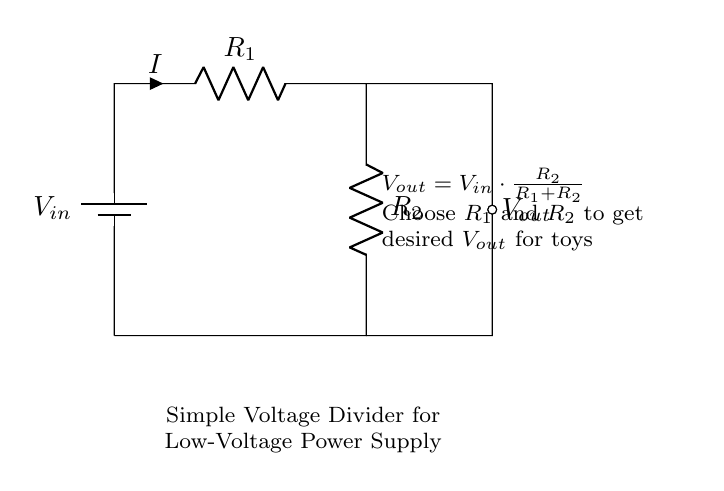What is the type of this circuit? This circuit is a voltage divider, which is specifically designed to produce a low voltage output from a higher voltage supply by using two resistors.
Answer: Voltage divider What are the components in the circuit? The components in this circuit are a battery, two resistors (R1 and R2), and a voltage output point. Each of these elements plays a crucial role in creating the desired voltage drop across the output.
Answer: Battery, R1, R2 What is the relationship between input voltage and output voltage? The output voltage is determined by the formula \(V_{out} = V_{in} \cdot \frac{R_2}{R_1 + R_2}\), indicating that the output voltage is proportional to the smaller resistor (R2) in relation to the total resistance of both resistors (R1 + R2).
Answer: Proportional relationship How can I calculate the output voltage of the divider? To calculate the output voltage, use the formula mentioned in the diagram, substituting the values for \(V_{in}\), \(R_1\), and \(R_2\). For example, if \(V_{in}\) is 9 volts, and R1 is 1k ohm and R2 is 2k ohms, plug these values into the formula to find \(V_{out}\).
Answer: By using the formula \(V_{out} = V_{in} \cdot \frac{R_2}{R_1 + R_2}\) What must be considered when choosing R1 and R2? When choosing R1 and R2, consider the desired output voltage for the toys and the total resistance, which affects the current flowing through the circuit. The chosen resistors should ensure the toy operates safely without overloading.
Answer: Desired output voltage What will happen if R2 is significantly larger than R1? If R2 is significantly larger than R1, the output voltage will approach the input voltage, which may not be safe for low-voltage toys as it can exceed their operating voltage limits. Thus, it is important to select appropriate resistor values to limit voltage.
Answer: Output voltage approaches input voltage 